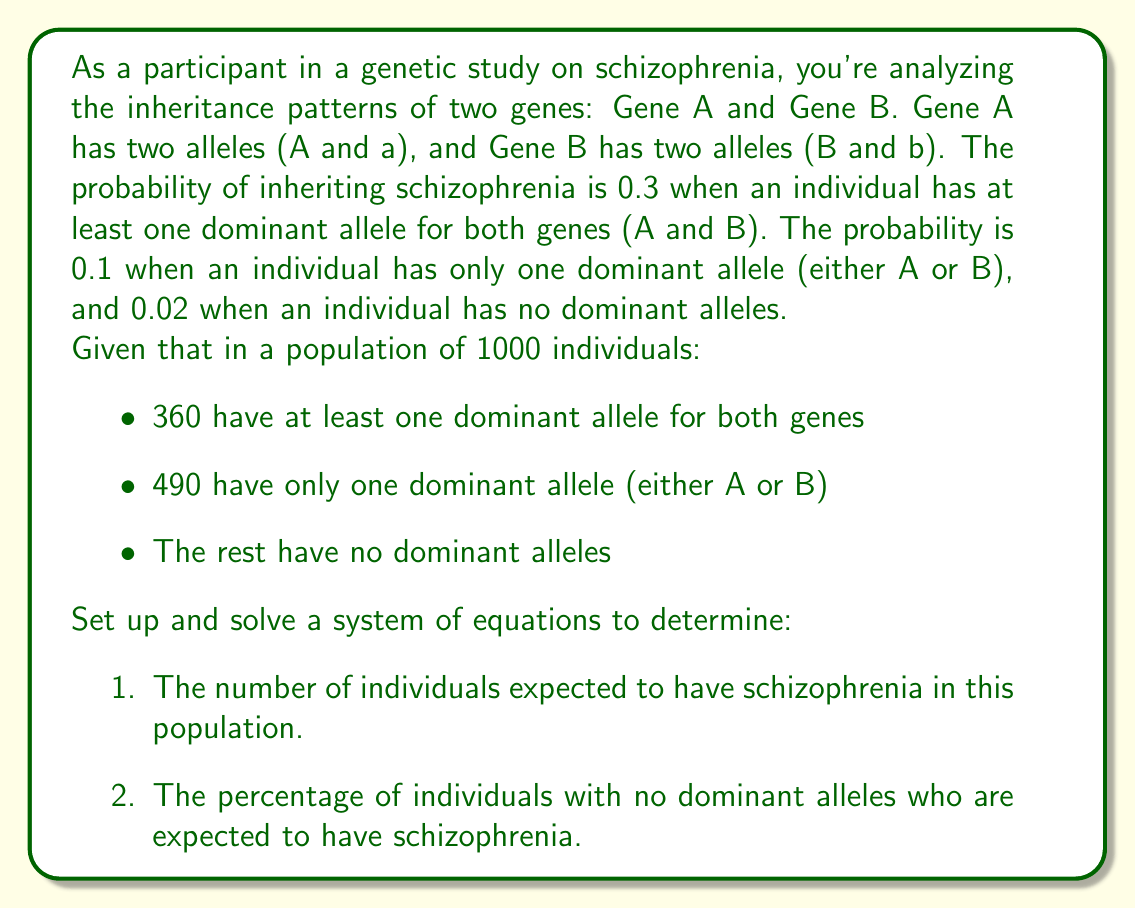Give your solution to this math problem. Let's approach this step-by-step:

1) First, let's define our variables:
   $x$ = number of individuals with schizophrenia who have at least one dominant allele for both genes
   $y$ = number of individuals with schizophrenia who have only one dominant allele
   $z$ = number of individuals with schizophrenia who have no dominant alleles

2) Now, we can set up our system of equations based on the given probabilities:

   $$\begin{cases}
   x = 0.3 \times 360 \\
   y = 0.1 \times 490 \\
   z = 0.02 \times (1000 - 360 - 490)
   \end{cases}$$

3) Let's solve each equation:

   $$\begin{align}
   x &= 0.3 \times 360 = 108 \\
   y &= 0.1 \times 490 = 49 \\
   z &= 0.02 \times (1000 - 360 - 490) = 0.02 \times 150 = 3
   \end{align}$$

4) To find the total number of individuals expected to have schizophrenia, we sum $x$, $y$, and $z$:

   Total = $x + y + z = 108 + 49 + 3 = 160$

5) To calculate the percentage of individuals with no dominant alleles who are expected to have schizophrenia:

   Percentage = $\frac{z}{\text{number of individuals with no dominant alleles}} \times 100\%$
               = $\frac{3}{150} \times 100\% = 2\%$
Answer: 1) The number of individuals expected to have schizophrenia in this population is 160.
2) The percentage of individuals with no dominant alleles who are expected to have schizophrenia is 2%. 